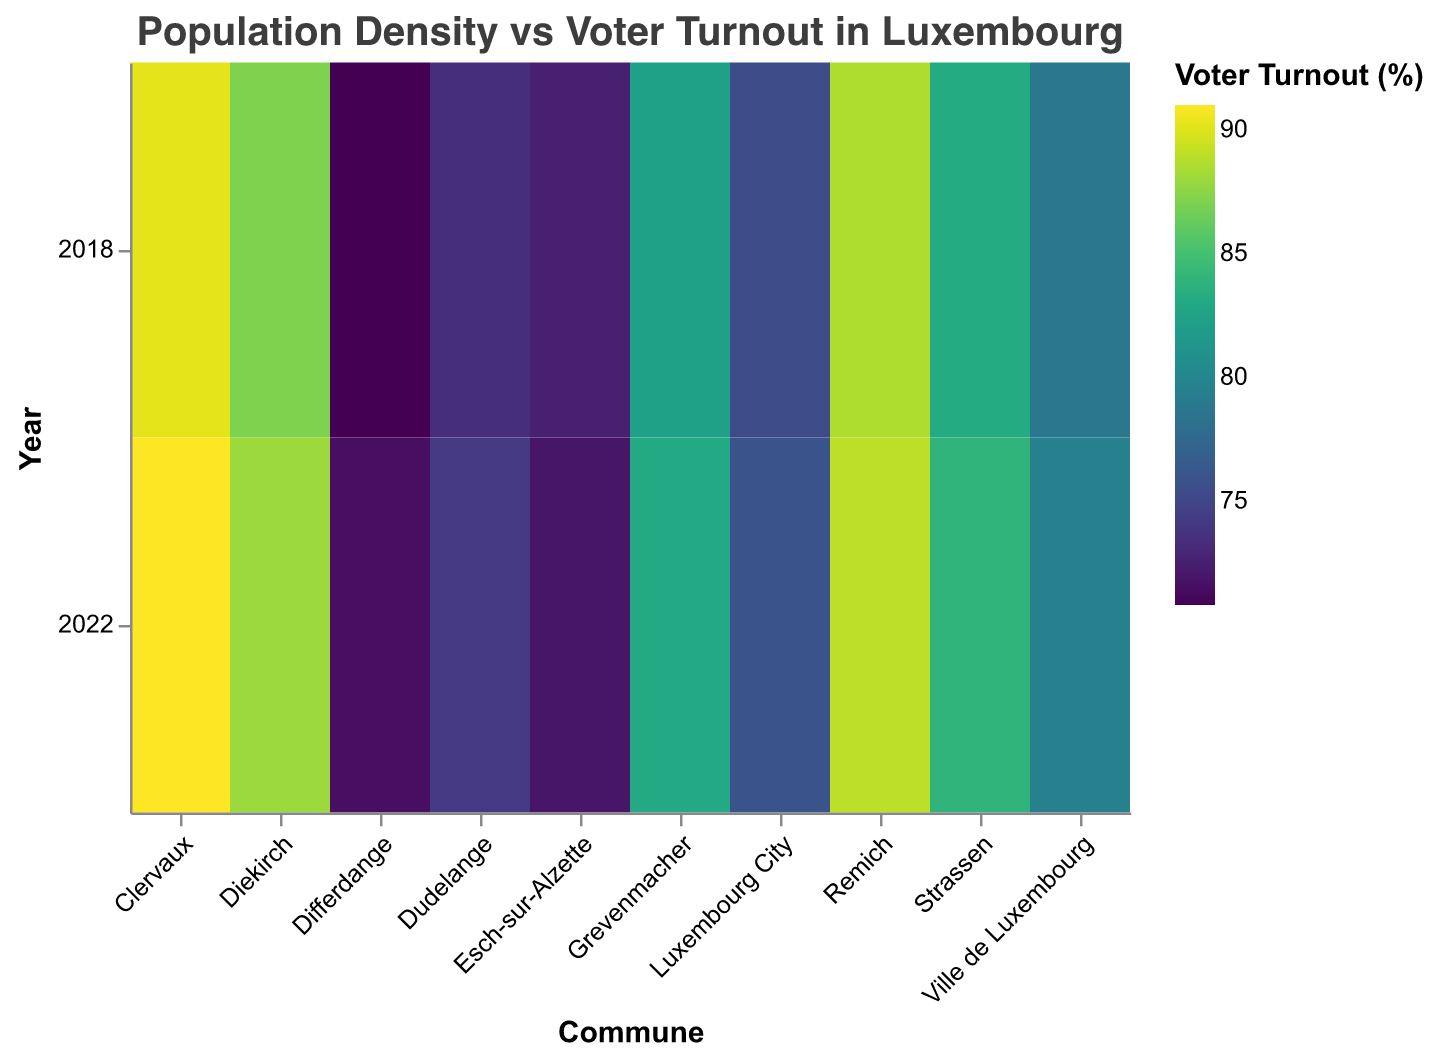What is the title of the heatmap? The title is usually displayed at the top of the heatmap, indicating the main focus or subject of the visualization. In this case, the title is "Population Density vs Voter Turnout in Luxembourg" as specified in the code.
Answer: Population Density vs Voter Turnout in Luxembourg Which commune had the highest voter turnout in 2018? To find the commune with the highest voter turnout in 2018, we need to compare the voter turnout values for each commune in that year. The highest value, 90.2%, corresponds to Clervaux.
Answer: Clervaux What is the color scheme used for representing voter turnout in the heatmap? The color scheme used for representing voter turnout is specified to be "viridis." This is a commonly used color palette in data visualizations, known for its perceptually uniform and colorblind-friendly properties.
Answer: viridis How does the voter turnout in Esch-sur-Alzette in 2022 compare to 2018? To compare voter turnout in Esch-sur-Alzette between 2018 and 2022, observe the values for both years. In 2018, the turnout was 72.5%, and in 2022, it was 71.9%. The turnout decreased slightly.
Answer: Decreased from 72.5% to 71.9% Which year had the highest average voter turnout across all communes? To determine the year with the highest average voter turnout, calculate the average turnout for each year. For 2018, sum the percentages (83.2 + 72.5 + 75.3 + 87.1 + 70.8 + 73.4 + 78.9 + 82.3 + 88.6 + 90.2) / 10 = 80.23%. For 2022, sum the percentages (84.0 + 71.9 + 76.0 + 88.0 + 71.5 + 74.1 + 79.5 + 83.0 + 89.0 + 91.0) / 10 = 80.8%. 2022 has the highest average.
Answer: 2022 Is there a noticeable pattern between population density and voter turnout based on the heatmap? Observing the heatmap, communes with lower population densities (like Clervaux and Remich) tend to have higher voter turnouts compared to those with higher population densities (like Esch-sur-Alzette and Differdange). This suggests an inverse relationship.
Answer: Inverse relationship Which commune shows the most significant increase in voter turnout from 2018 to 2022? To find the most significant increase, calculate the change in voter turnout for each commune. The largest positive difference is observed in Clervaux, which increased from 90.2% to 91.0%, a change of 0.8%.
Answer: Clervaux How does voter turnout in Ville de Luxembourg compare to Luxembourg City in 2022? Compare the voter turnout values for both communes in 2022. Ville de Luxembourg has a turnout of 79.5%, while Luxembourg City has 76.0%. Ville de Luxembourg has a higher turnout.
Answer: Ville de Luxembourg has a higher turnout Which two communes had the closest voter turnout in 2022? Compare the voter turnout values for all communes in 2022. Strassen (84.0%) and Grevenmacher (83.0%) have the closest turnouts, with a difference of only 1.0%.
Answer: Strassen and Grevenmacher What is the average voter turnout for all communes in 2018? Calculate the average by summing all voter turnout percentages for 2018 and dividing by the number of communes. Sum: 83.2 + 72.5 + 75.3 + 87.1 + 70.8 + 73.4 + 78.9 + 82.3 + 88.6 + 90.2 = 802.3. Average: 802.3/10 = 80.23
Answer: 80.23 